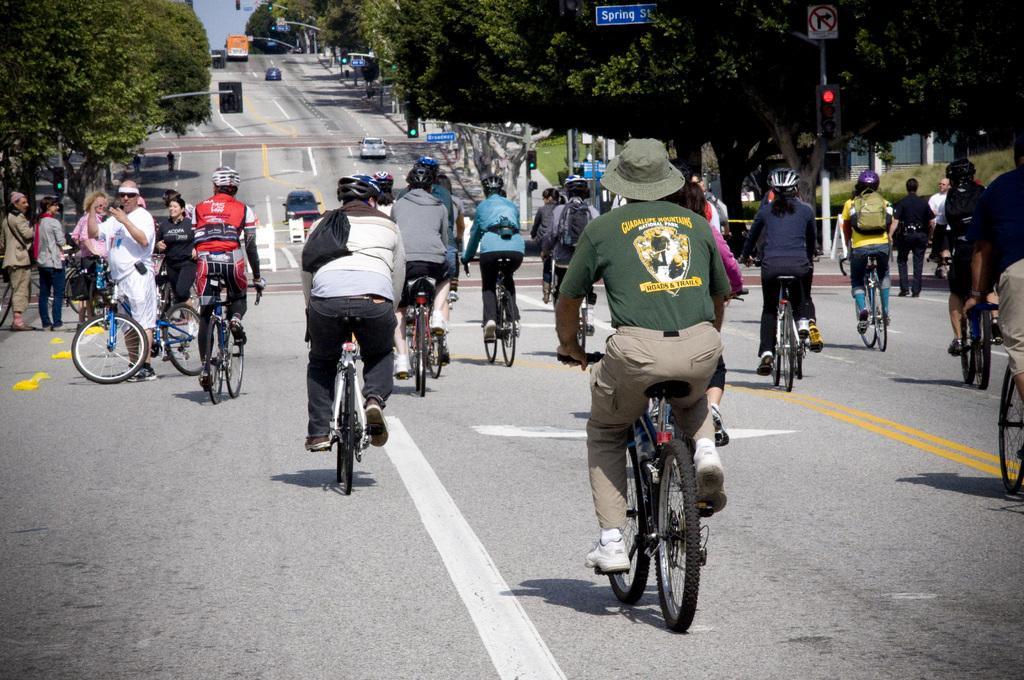In one or two sentences, can you explain what this image depicts? As we can see in the image there are few people riding bicycles and on road there are vehicles and there are trees and traffic signal. 